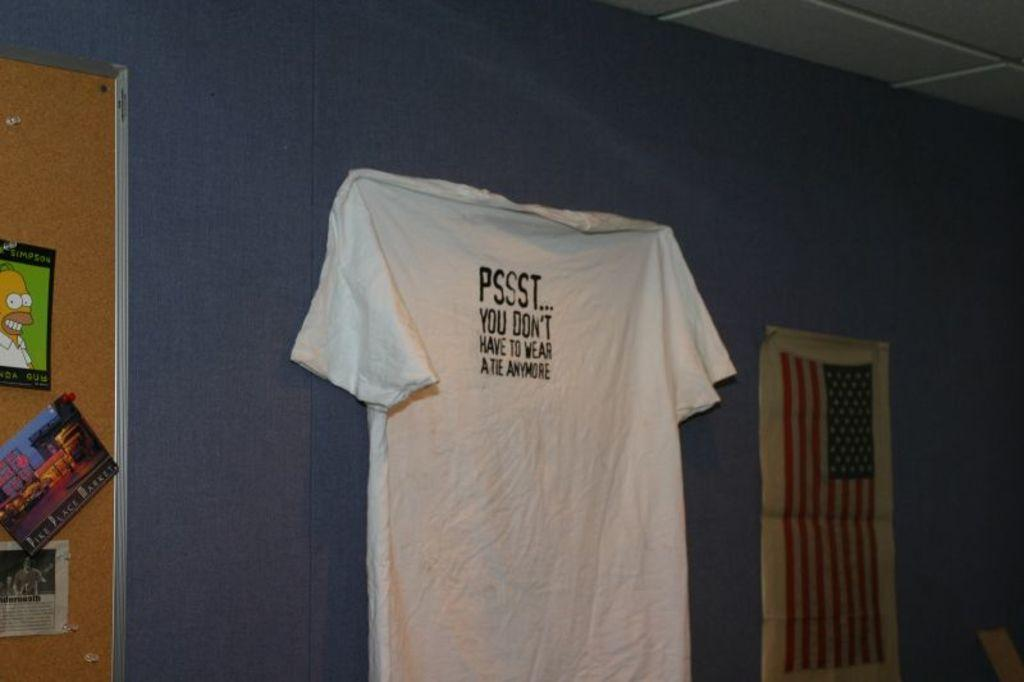<image>
Share a concise interpretation of the image provided. A white t-shirt with the slogan Psst.. you don;t have to wear a tie anymore is pinned to a blue wall. 